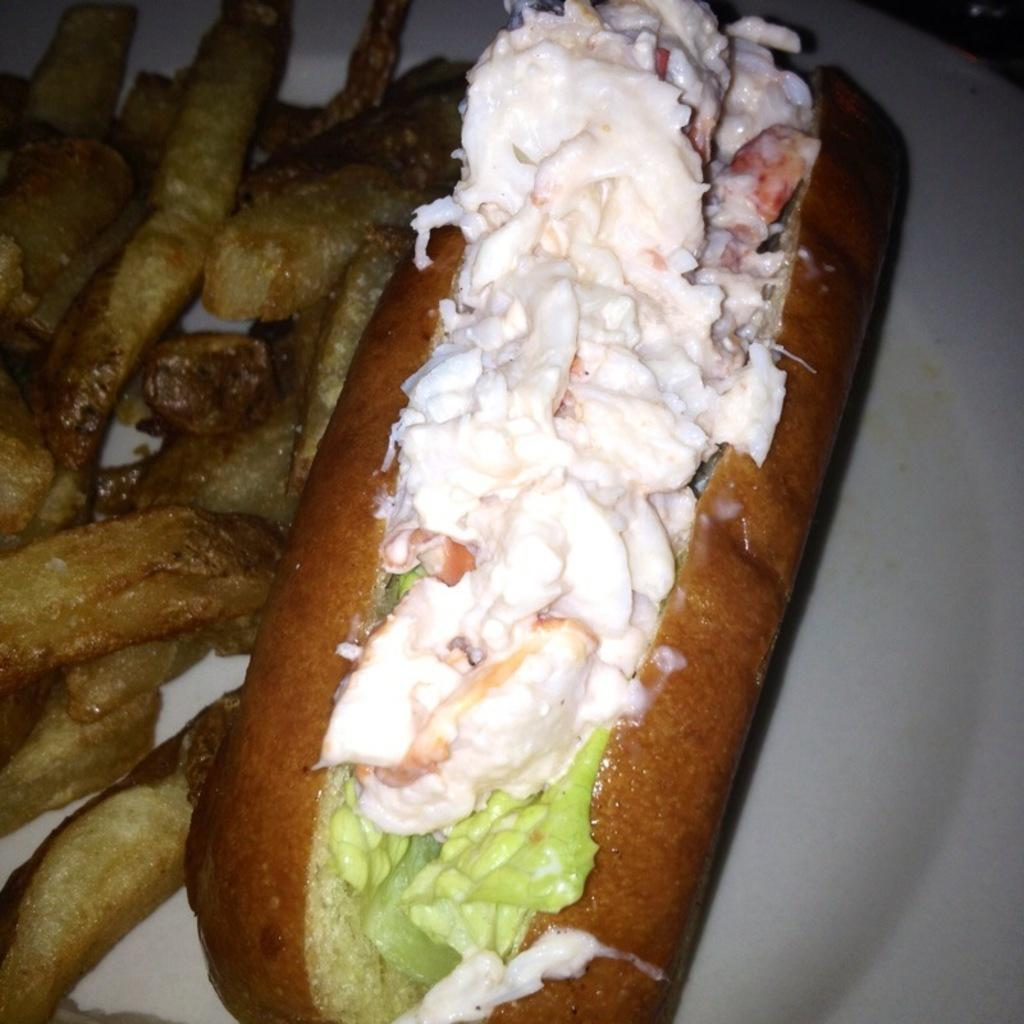What color is the plate in the image? The plate in the image is white. What is on the plate in the image? There are food items on the plate in the image. Can you identify any specific food item on the plate? Yes, the food items include fries. How many dresses are hanging on the wall in the image? There are no dresses present in the image; it only features a white color plate with food items on it. 